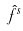<formula> <loc_0><loc_0><loc_500><loc_500>\hat { f } ^ { s }</formula> 